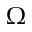<formula> <loc_0><loc_0><loc_500><loc_500>\Omega</formula> 